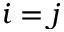<formula> <loc_0><loc_0><loc_500><loc_500>i = j</formula> 